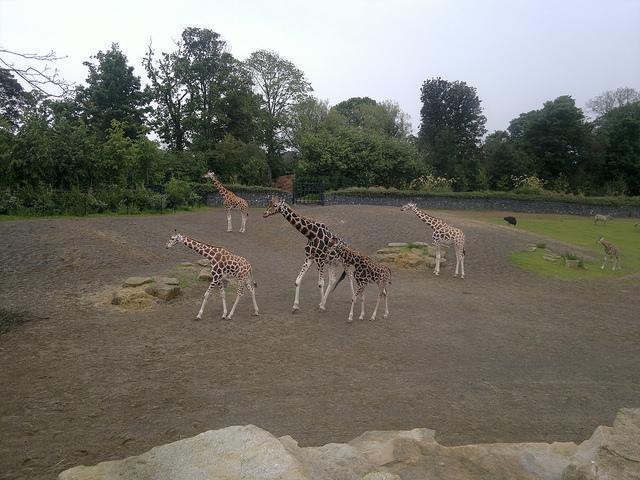What feature do the animals have?
Indicate the correct choice and explain in the format: 'Answer: answer
Rationale: rationale.'
Options: Spots, gills, wings, talons. Answer: spots.
Rationale: Giraffes are grazing in an open area. 